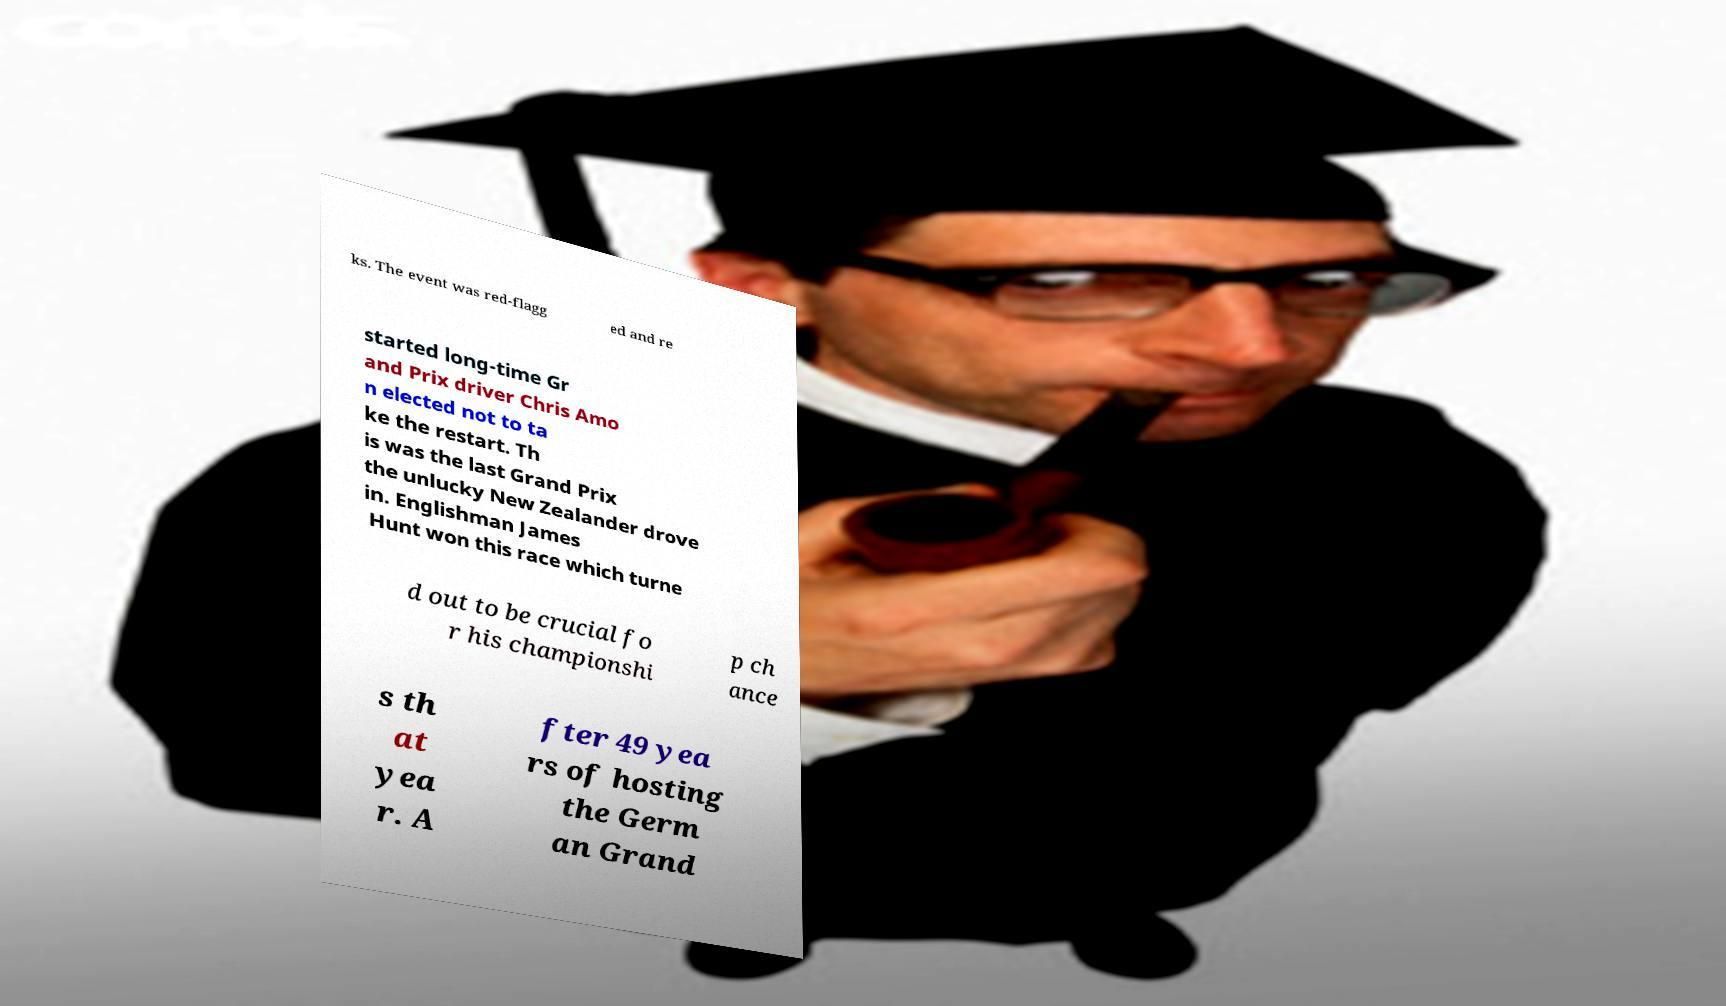Could you extract and type out the text from this image? ks. The event was red-flagg ed and re started long-time Gr and Prix driver Chris Amo n elected not to ta ke the restart. Th is was the last Grand Prix the unlucky New Zealander drove in. Englishman James Hunt won this race which turne d out to be crucial fo r his championshi p ch ance s th at yea r. A fter 49 yea rs of hosting the Germ an Grand 